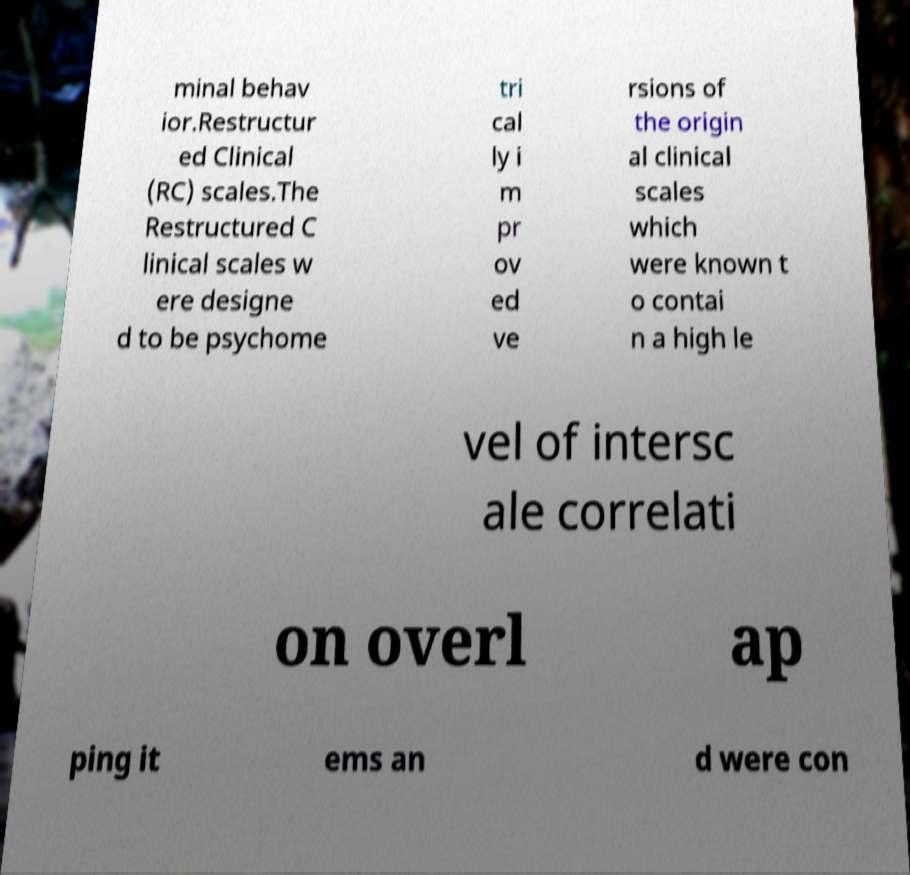I need the written content from this picture converted into text. Can you do that? minal behav ior.Restructur ed Clinical (RC) scales.The Restructured C linical scales w ere designe d to be psychome tri cal ly i m pr ov ed ve rsions of the origin al clinical scales which were known t o contai n a high le vel of intersc ale correlati on overl ap ping it ems an d were con 